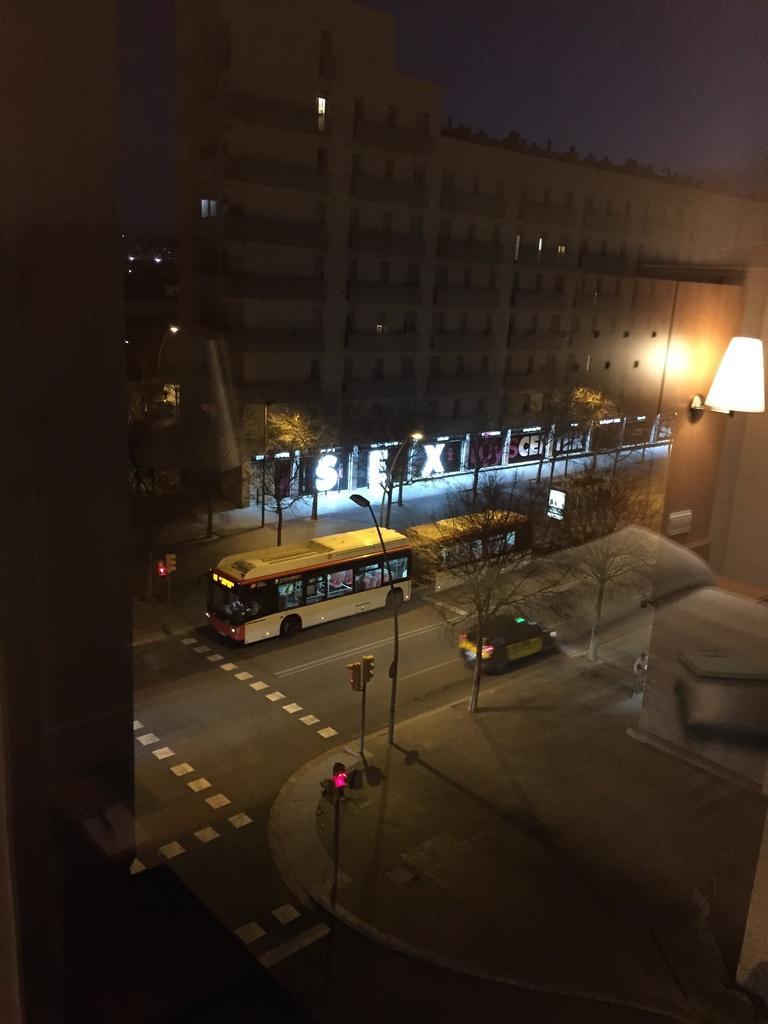Describe this image in one or two sentences. In the picture I can see the vehicles on the road. I can see the light poles on both sides of the road. I can see a traffic signal pole on the side of the road. In the background, I can see the building. 